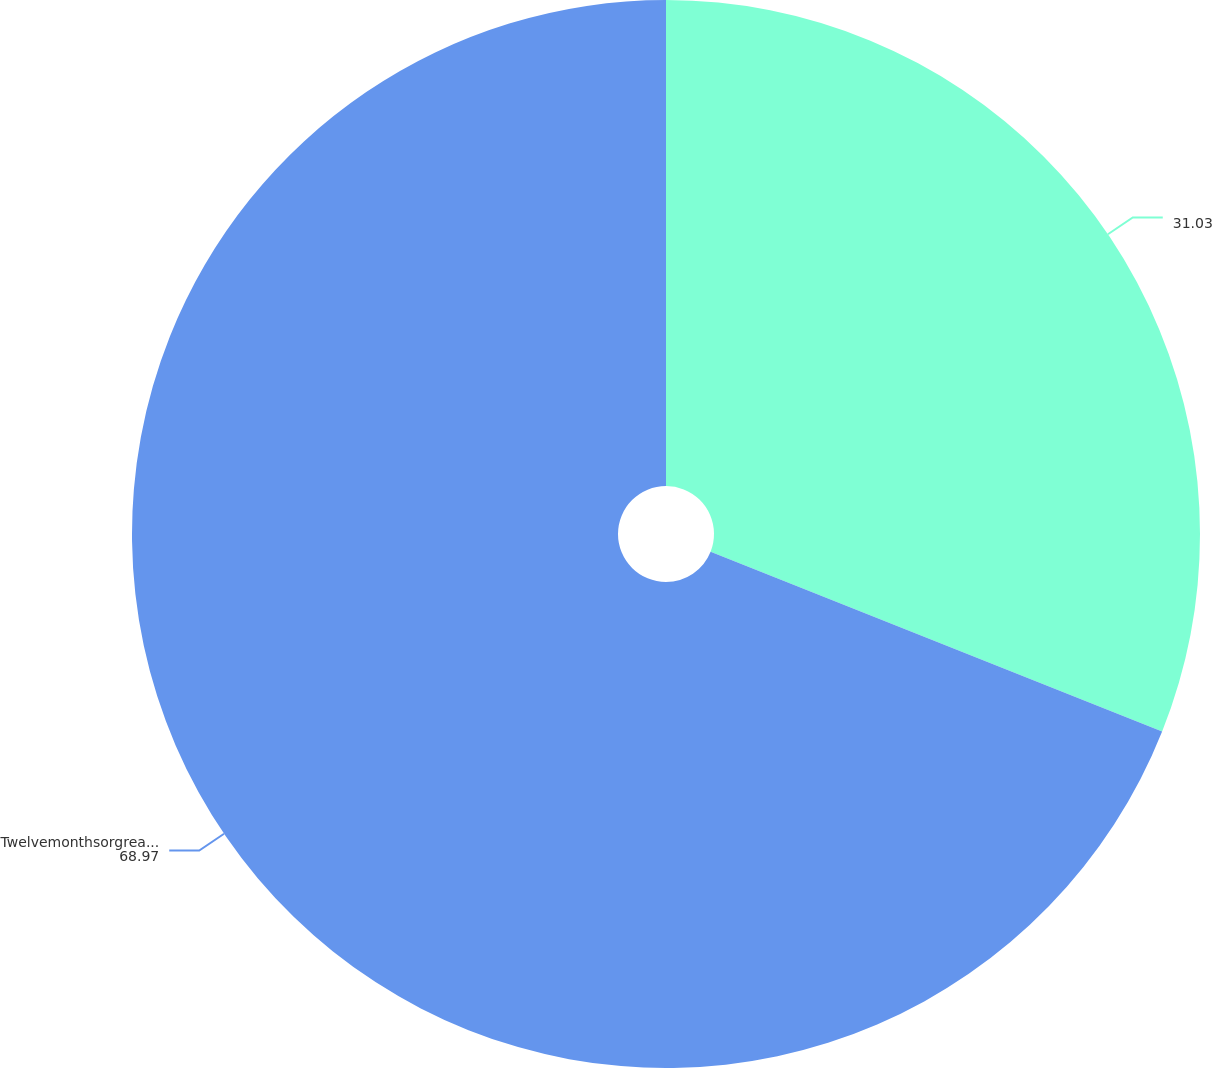<chart> <loc_0><loc_0><loc_500><loc_500><pie_chart><ecel><fcel>Twelvemonthsorgreater<nl><fcel>31.03%<fcel>68.97%<nl></chart> 